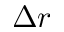Convert formula to latex. <formula><loc_0><loc_0><loc_500><loc_500>\Delta r</formula> 